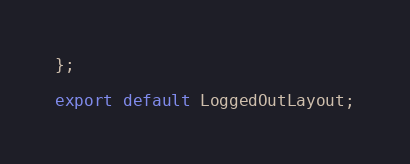<code> <loc_0><loc_0><loc_500><loc_500><_JavaScript_>};

export default LoggedOutLayout;
</code> 